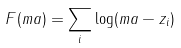<formula> <loc_0><loc_0><loc_500><loc_500>F ( m a ) = \sum _ { i } \log ( m a - z _ { i } )</formula> 